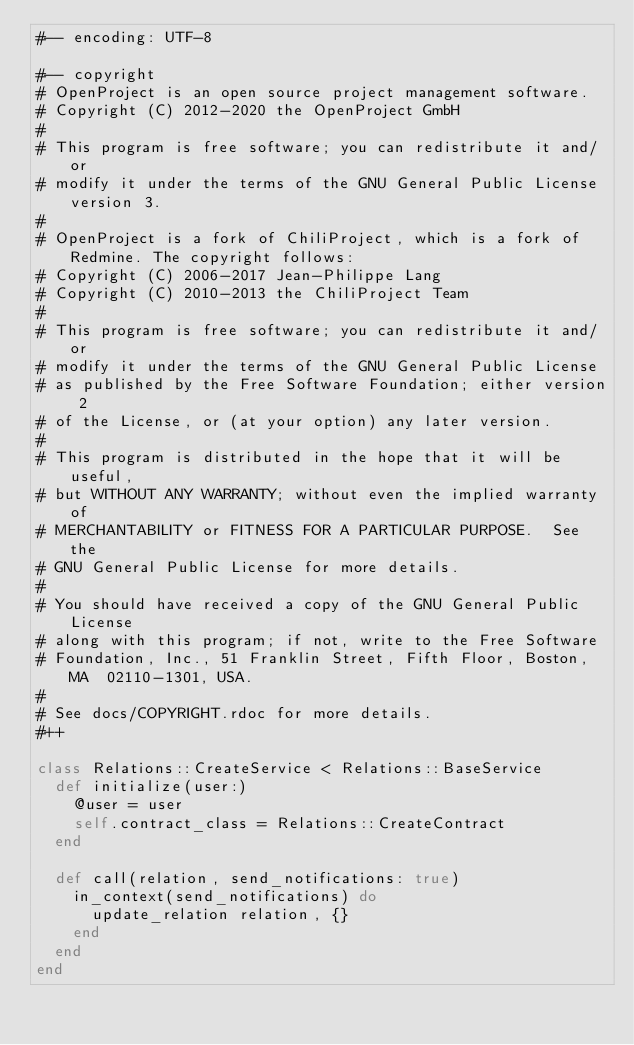<code> <loc_0><loc_0><loc_500><loc_500><_Ruby_>#-- encoding: UTF-8

#-- copyright
# OpenProject is an open source project management software.
# Copyright (C) 2012-2020 the OpenProject GmbH
#
# This program is free software; you can redistribute it and/or
# modify it under the terms of the GNU General Public License version 3.
#
# OpenProject is a fork of ChiliProject, which is a fork of Redmine. The copyright follows:
# Copyright (C) 2006-2017 Jean-Philippe Lang
# Copyright (C) 2010-2013 the ChiliProject Team
#
# This program is free software; you can redistribute it and/or
# modify it under the terms of the GNU General Public License
# as published by the Free Software Foundation; either version 2
# of the License, or (at your option) any later version.
#
# This program is distributed in the hope that it will be useful,
# but WITHOUT ANY WARRANTY; without even the implied warranty of
# MERCHANTABILITY or FITNESS FOR A PARTICULAR PURPOSE.  See the
# GNU General Public License for more details.
#
# You should have received a copy of the GNU General Public License
# along with this program; if not, write to the Free Software
# Foundation, Inc., 51 Franklin Street, Fifth Floor, Boston, MA  02110-1301, USA.
#
# See docs/COPYRIGHT.rdoc for more details.
#++

class Relations::CreateService < Relations::BaseService
  def initialize(user:)
    @user = user
    self.contract_class = Relations::CreateContract
  end

  def call(relation, send_notifications: true)
    in_context(send_notifications) do
      update_relation relation, {}
    end
  end
end
</code> 